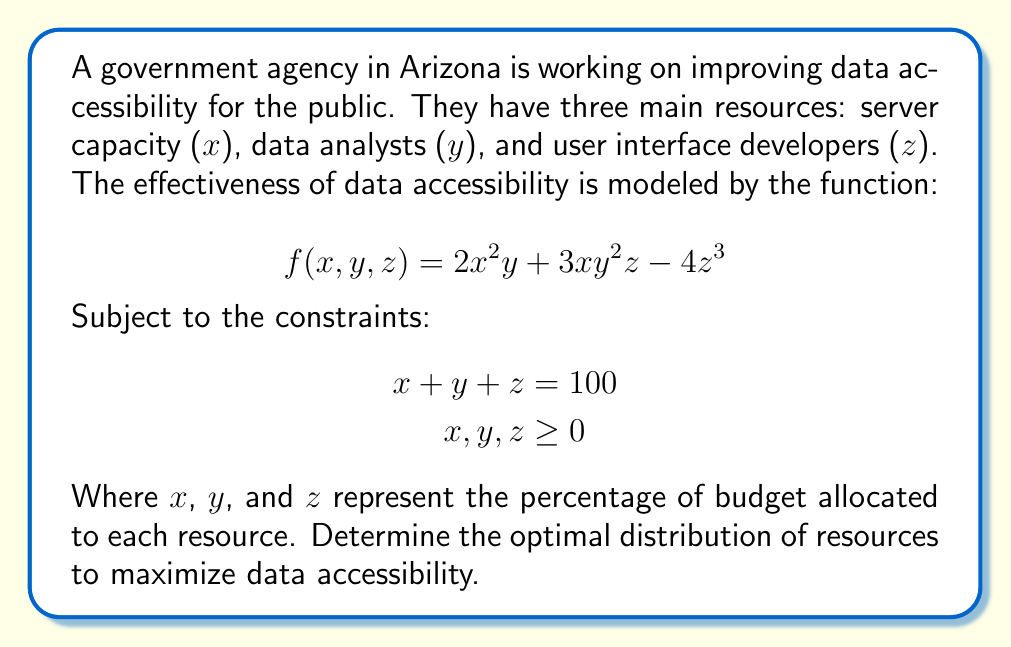What is the answer to this math problem? To solve this optimization problem with constraints, we'll use the method of Lagrange multipliers.

1) First, we form the Lagrangian function:
   $$L(x,y,z,\lambda) = 2x^2y + 3xy^2z - 4z^3 - \lambda(x + y + z - 100)$$

2) Now, we take partial derivatives and set them equal to zero:
   $$\frac{\partial L}{\partial x} = 4xy + 3y^2z - \lambda = 0$$
   $$\frac{\partial L}{\partial y} = 2x^2 + 6xyz - \lambda = 0$$
   $$\frac{\partial L}{\partial z} = 3xy^2 - 12z^2 - \lambda = 0$$
   $$\frac{\partial L}{\partial \lambda} = x + y + z - 100 = 0$$

3) From the first three equations:
   $$4xy + 3y^2z = 2x^2 + 6xyz = 3xy^2 - 12z^2$$

4) Dividing the first two equations:
   $$\frac{4xy + 3y^2z}{2x^2 + 6xyz} = 1$$
   $$4xy + 3y^2z = 2x^2 + 6xyz$$
   $$4xy - 2x^2 = 6xyz - 3y^2z$$
   $$2x(2y - x) = 3yz(2x - y)$$

5) This implies either $x = 2y$ or $z = 0$. If $z = 0$, it wouldn't be optimal as we need all resources. So, $x = 2y$.

6) Substituting this into the constraint equation:
   $$2y + y + z = 100$$
   $$3y + z = 100$$

7) Now, from step 3:
   $$3y^3 - 12z^2 = 8y^3 + 12y^2z$$
   $$12z^2 + 12y^2z + 5y^3 = 0$$
   $$12z^2 + 12y^2z = -5y^3$$
   $$z^2 + y^2z = -\frac{5}{12}y^3$$

8) Substituting $z = 100 - 3y$ from step 6:
   $$(100 - 3y)^2 + y^2(100 - 3y) = -\frac{5}{12}y^3$$
   $$10000 - 600y + 9y^2 + 100y^2 - 3y^3 = -\frac{5}{12}y^3$$
   $$10000 - 600y + 109y^2 + \frac{31}{12}y^3 = 0$$

9) Solving this equation numerically gives $y \approx 20$.

10) Therefore, $x \approx 40$ and $z \approx 40$.
Answer: The optimal distribution of resources is approximately:
Server capacity ($x$): 40%
Data analysts ($y$): 20%
User interface developers ($z$): 40% 